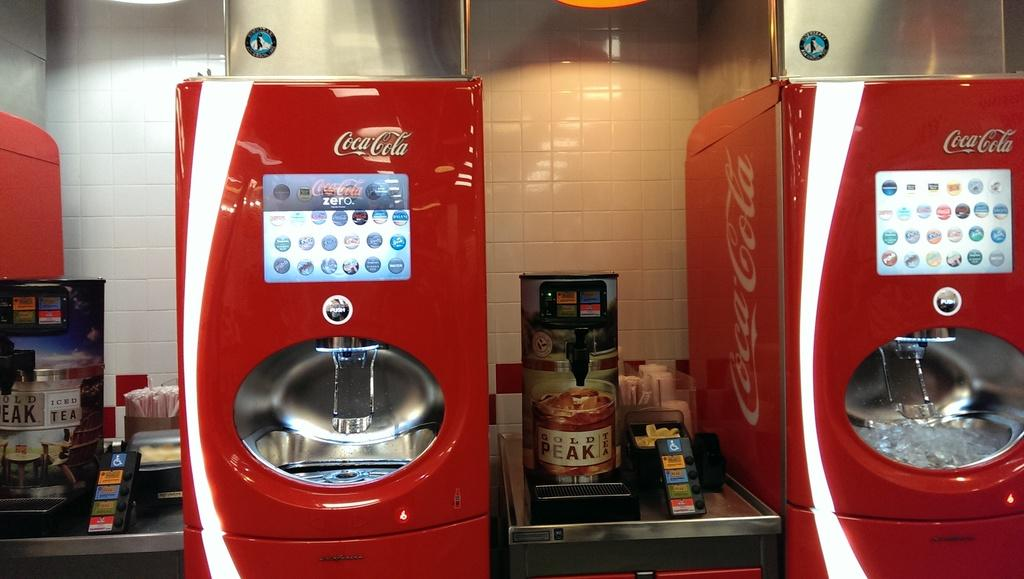<image>
Present a compact description of the photo's key features. Coca Cola vending machines next to coffee machines in a cafeteria setting 